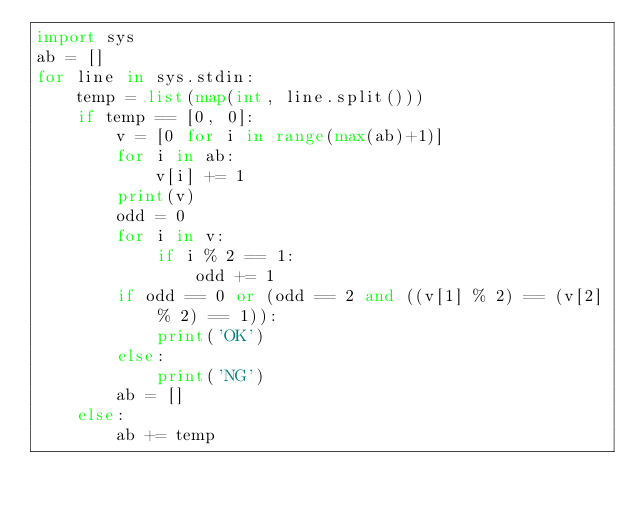Convert code to text. <code><loc_0><loc_0><loc_500><loc_500><_Python_>import sys
ab = []
for line in sys.stdin:
    temp = list(map(int, line.split()))
    if temp == [0, 0]:
        v = [0 for i in range(max(ab)+1)]
        for i in ab:
            v[i] += 1
        print(v)
        odd = 0
        for i in v:
            if i % 2 == 1:
                odd += 1
        if odd == 0 or (odd == 2 and ((v[1] % 2) == (v[2] % 2) == 1)):
            print('OK')
        else:
            print('NG')
        ab = []
    else:
        ab += temp

</code> 